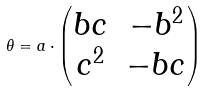<formula> <loc_0><loc_0><loc_500><loc_500>\theta = a \cdot \begin{pmatrix} b c & - b ^ { 2 } \\ c ^ { 2 } & - b c \end{pmatrix}</formula> 